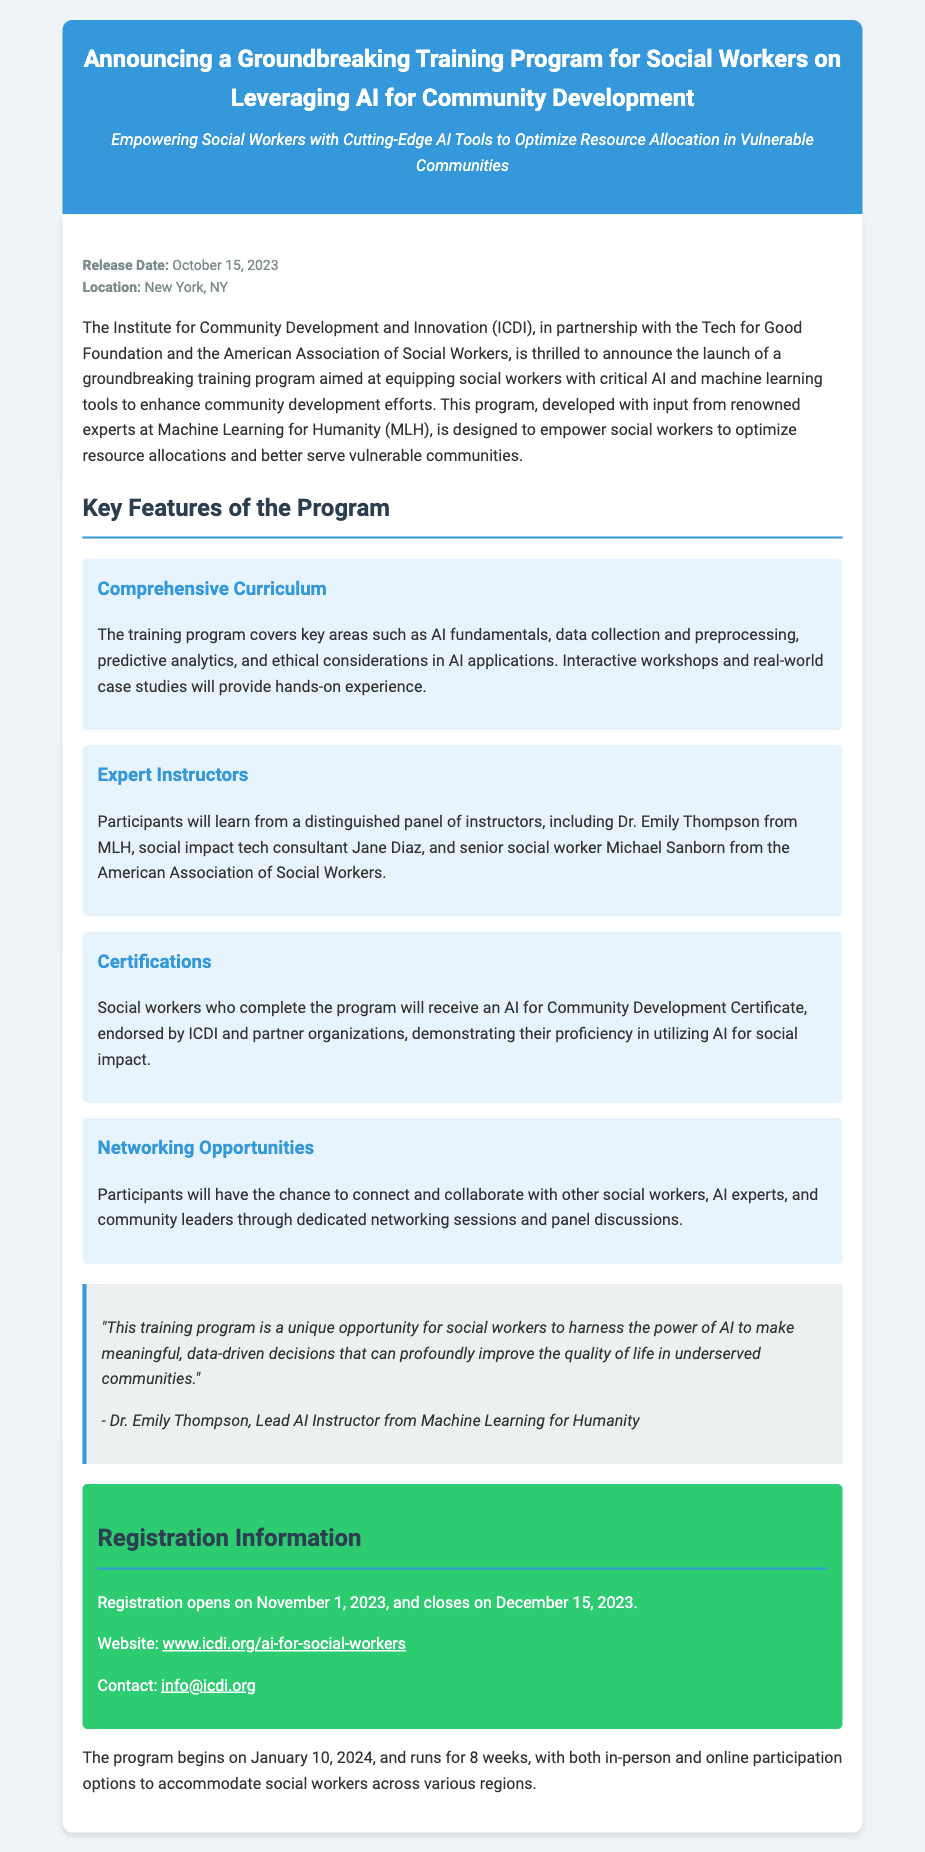What is the release date? The release date of the press release is explicitly mentioned in the document.
Answer: October 15, 2023 Where is the program being launched? The document states the location of the program announcement.
Answer: New York, NY Who is the lead AI instructor? The document names the lead instructor for the program.
Answer: Dr. Emily Thompson How long is the program? The duration of the training program is specified in the document.
Answer: 8 weeks When does registration open? The document provides the date when registration for the program begins.
Answer: November 1, 2023 What certificate do participants receive? The program offers a specific certification upon completion, which is mentioned in the document.
Answer: AI for Community Development Certificate What are the networking opportunities for participants? The document describes an aspect of the program related to collaboration and connection among participants.
Answer: Networking sessions and panel discussions How many organizations partnered for this program? The document lists several organizations involved in the program, which can be counted for this answer.
Answer: Three 